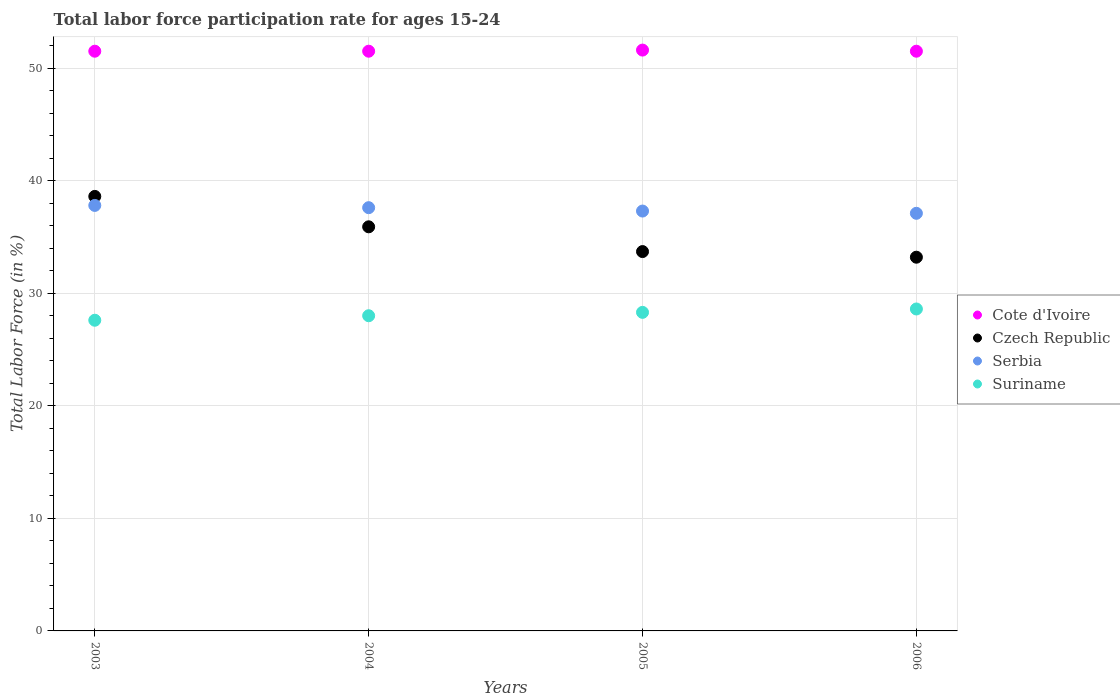How many different coloured dotlines are there?
Offer a terse response. 4. What is the labor force participation rate in Czech Republic in 2003?
Provide a short and direct response. 38.6. Across all years, what is the maximum labor force participation rate in Suriname?
Keep it short and to the point. 28.6. Across all years, what is the minimum labor force participation rate in Cote d'Ivoire?
Your response must be concise. 51.5. In which year was the labor force participation rate in Suriname maximum?
Ensure brevity in your answer.  2006. What is the total labor force participation rate in Czech Republic in the graph?
Provide a short and direct response. 141.4. What is the difference between the labor force participation rate in Cote d'Ivoire in 2004 and that in 2005?
Ensure brevity in your answer.  -0.1. What is the difference between the labor force participation rate in Serbia in 2006 and the labor force participation rate in Cote d'Ivoire in 2005?
Provide a short and direct response. -14.5. What is the average labor force participation rate in Czech Republic per year?
Provide a succinct answer. 35.35. In the year 2003, what is the difference between the labor force participation rate in Serbia and labor force participation rate in Czech Republic?
Provide a short and direct response. -0.8. What is the ratio of the labor force participation rate in Serbia in 2005 to that in 2006?
Your answer should be compact. 1.01. Is the labor force participation rate in Cote d'Ivoire in 2004 less than that in 2006?
Keep it short and to the point. No. Is the difference between the labor force participation rate in Serbia in 2004 and 2005 greater than the difference between the labor force participation rate in Czech Republic in 2004 and 2005?
Keep it short and to the point. No. What is the difference between the highest and the second highest labor force participation rate in Serbia?
Offer a very short reply. 0.2. What is the difference between the highest and the lowest labor force participation rate in Serbia?
Provide a short and direct response. 0.7. Is the sum of the labor force participation rate in Suriname in 2003 and 2004 greater than the maximum labor force participation rate in Serbia across all years?
Give a very brief answer. Yes. Is the labor force participation rate in Czech Republic strictly less than the labor force participation rate in Suriname over the years?
Ensure brevity in your answer.  No. How many dotlines are there?
Offer a terse response. 4. What is the difference between two consecutive major ticks on the Y-axis?
Provide a short and direct response. 10. Does the graph contain any zero values?
Provide a short and direct response. No. What is the title of the graph?
Offer a very short reply. Total labor force participation rate for ages 15-24. What is the label or title of the X-axis?
Keep it short and to the point. Years. What is the label or title of the Y-axis?
Make the answer very short. Total Labor Force (in %). What is the Total Labor Force (in %) in Cote d'Ivoire in 2003?
Your answer should be very brief. 51.5. What is the Total Labor Force (in %) in Czech Republic in 2003?
Your answer should be very brief. 38.6. What is the Total Labor Force (in %) of Serbia in 2003?
Provide a short and direct response. 37.8. What is the Total Labor Force (in %) in Suriname in 2003?
Give a very brief answer. 27.6. What is the Total Labor Force (in %) of Cote d'Ivoire in 2004?
Your answer should be compact. 51.5. What is the Total Labor Force (in %) in Czech Republic in 2004?
Give a very brief answer. 35.9. What is the Total Labor Force (in %) in Serbia in 2004?
Your answer should be compact. 37.6. What is the Total Labor Force (in %) in Suriname in 2004?
Your response must be concise. 28. What is the Total Labor Force (in %) in Cote d'Ivoire in 2005?
Your answer should be compact. 51.6. What is the Total Labor Force (in %) in Czech Republic in 2005?
Provide a succinct answer. 33.7. What is the Total Labor Force (in %) in Serbia in 2005?
Keep it short and to the point. 37.3. What is the Total Labor Force (in %) of Suriname in 2005?
Provide a succinct answer. 28.3. What is the Total Labor Force (in %) in Cote d'Ivoire in 2006?
Ensure brevity in your answer.  51.5. What is the Total Labor Force (in %) of Czech Republic in 2006?
Offer a very short reply. 33.2. What is the Total Labor Force (in %) of Serbia in 2006?
Ensure brevity in your answer.  37.1. What is the Total Labor Force (in %) of Suriname in 2006?
Make the answer very short. 28.6. Across all years, what is the maximum Total Labor Force (in %) in Cote d'Ivoire?
Provide a succinct answer. 51.6. Across all years, what is the maximum Total Labor Force (in %) of Czech Republic?
Your answer should be very brief. 38.6. Across all years, what is the maximum Total Labor Force (in %) of Serbia?
Give a very brief answer. 37.8. Across all years, what is the maximum Total Labor Force (in %) in Suriname?
Your response must be concise. 28.6. Across all years, what is the minimum Total Labor Force (in %) in Cote d'Ivoire?
Make the answer very short. 51.5. Across all years, what is the minimum Total Labor Force (in %) of Czech Republic?
Your answer should be very brief. 33.2. Across all years, what is the minimum Total Labor Force (in %) in Serbia?
Your answer should be very brief. 37.1. Across all years, what is the minimum Total Labor Force (in %) in Suriname?
Offer a terse response. 27.6. What is the total Total Labor Force (in %) of Cote d'Ivoire in the graph?
Make the answer very short. 206.1. What is the total Total Labor Force (in %) in Czech Republic in the graph?
Your answer should be compact. 141.4. What is the total Total Labor Force (in %) in Serbia in the graph?
Offer a very short reply. 149.8. What is the total Total Labor Force (in %) in Suriname in the graph?
Keep it short and to the point. 112.5. What is the difference between the Total Labor Force (in %) in Suriname in 2003 and that in 2004?
Give a very brief answer. -0.4. What is the difference between the Total Labor Force (in %) in Cote d'Ivoire in 2003 and that in 2005?
Your answer should be very brief. -0.1. What is the difference between the Total Labor Force (in %) of Cote d'Ivoire in 2003 and that in 2006?
Make the answer very short. 0. What is the difference between the Total Labor Force (in %) in Serbia in 2003 and that in 2006?
Your answer should be very brief. 0.7. What is the difference between the Total Labor Force (in %) in Suriname in 2003 and that in 2006?
Offer a very short reply. -1. What is the difference between the Total Labor Force (in %) in Czech Republic in 2004 and that in 2005?
Offer a terse response. 2.2. What is the difference between the Total Labor Force (in %) of Serbia in 2004 and that in 2005?
Ensure brevity in your answer.  0.3. What is the difference between the Total Labor Force (in %) of Suriname in 2004 and that in 2005?
Your response must be concise. -0.3. What is the difference between the Total Labor Force (in %) of Cote d'Ivoire in 2004 and that in 2006?
Provide a succinct answer. 0. What is the difference between the Total Labor Force (in %) in Czech Republic in 2004 and that in 2006?
Provide a succinct answer. 2.7. What is the difference between the Total Labor Force (in %) of Serbia in 2004 and that in 2006?
Give a very brief answer. 0.5. What is the difference between the Total Labor Force (in %) of Cote d'Ivoire in 2005 and that in 2006?
Keep it short and to the point. 0.1. What is the difference between the Total Labor Force (in %) of Czech Republic in 2005 and that in 2006?
Keep it short and to the point. 0.5. What is the difference between the Total Labor Force (in %) of Suriname in 2005 and that in 2006?
Ensure brevity in your answer.  -0.3. What is the difference between the Total Labor Force (in %) of Cote d'Ivoire in 2003 and the Total Labor Force (in %) of Czech Republic in 2004?
Provide a succinct answer. 15.6. What is the difference between the Total Labor Force (in %) in Serbia in 2003 and the Total Labor Force (in %) in Suriname in 2004?
Provide a short and direct response. 9.8. What is the difference between the Total Labor Force (in %) in Cote d'Ivoire in 2003 and the Total Labor Force (in %) in Serbia in 2005?
Give a very brief answer. 14.2. What is the difference between the Total Labor Force (in %) of Cote d'Ivoire in 2003 and the Total Labor Force (in %) of Suriname in 2005?
Offer a terse response. 23.2. What is the difference between the Total Labor Force (in %) in Czech Republic in 2003 and the Total Labor Force (in %) in Suriname in 2005?
Ensure brevity in your answer.  10.3. What is the difference between the Total Labor Force (in %) of Cote d'Ivoire in 2003 and the Total Labor Force (in %) of Suriname in 2006?
Your answer should be compact. 22.9. What is the difference between the Total Labor Force (in %) in Serbia in 2003 and the Total Labor Force (in %) in Suriname in 2006?
Your answer should be compact. 9.2. What is the difference between the Total Labor Force (in %) of Cote d'Ivoire in 2004 and the Total Labor Force (in %) of Czech Republic in 2005?
Your response must be concise. 17.8. What is the difference between the Total Labor Force (in %) in Cote d'Ivoire in 2004 and the Total Labor Force (in %) in Suriname in 2005?
Ensure brevity in your answer.  23.2. What is the difference between the Total Labor Force (in %) in Cote d'Ivoire in 2004 and the Total Labor Force (in %) in Czech Republic in 2006?
Provide a succinct answer. 18.3. What is the difference between the Total Labor Force (in %) in Cote d'Ivoire in 2004 and the Total Labor Force (in %) in Suriname in 2006?
Your answer should be compact. 22.9. What is the difference between the Total Labor Force (in %) of Cote d'Ivoire in 2005 and the Total Labor Force (in %) of Serbia in 2006?
Your answer should be very brief. 14.5. What is the difference between the Total Labor Force (in %) of Serbia in 2005 and the Total Labor Force (in %) of Suriname in 2006?
Make the answer very short. 8.7. What is the average Total Labor Force (in %) in Cote d'Ivoire per year?
Your answer should be compact. 51.52. What is the average Total Labor Force (in %) in Czech Republic per year?
Provide a short and direct response. 35.35. What is the average Total Labor Force (in %) in Serbia per year?
Your answer should be very brief. 37.45. What is the average Total Labor Force (in %) of Suriname per year?
Provide a short and direct response. 28.12. In the year 2003, what is the difference between the Total Labor Force (in %) of Cote d'Ivoire and Total Labor Force (in %) of Suriname?
Provide a short and direct response. 23.9. In the year 2003, what is the difference between the Total Labor Force (in %) of Czech Republic and Total Labor Force (in %) of Suriname?
Your answer should be compact. 11. In the year 2004, what is the difference between the Total Labor Force (in %) in Cote d'Ivoire and Total Labor Force (in %) in Suriname?
Offer a very short reply. 23.5. In the year 2004, what is the difference between the Total Labor Force (in %) in Czech Republic and Total Labor Force (in %) in Serbia?
Offer a terse response. -1.7. In the year 2005, what is the difference between the Total Labor Force (in %) of Cote d'Ivoire and Total Labor Force (in %) of Czech Republic?
Your answer should be compact. 17.9. In the year 2005, what is the difference between the Total Labor Force (in %) of Cote d'Ivoire and Total Labor Force (in %) of Serbia?
Your answer should be very brief. 14.3. In the year 2005, what is the difference between the Total Labor Force (in %) in Cote d'Ivoire and Total Labor Force (in %) in Suriname?
Keep it short and to the point. 23.3. In the year 2006, what is the difference between the Total Labor Force (in %) in Cote d'Ivoire and Total Labor Force (in %) in Czech Republic?
Ensure brevity in your answer.  18.3. In the year 2006, what is the difference between the Total Labor Force (in %) of Cote d'Ivoire and Total Labor Force (in %) of Suriname?
Ensure brevity in your answer.  22.9. In the year 2006, what is the difference between the Total Labor Force (in %) in Czech Republic and Total Labor Force (in %) in Suriname?
Your response must be concise. 4.6. In the year 2006, what is the difference between the Total Labor Force (in %) in Serbia and Total Labor Force (in %) in Suriname?
Provide a short and direct response. 8.5. What is the ratio of the Total Labor Force (in %) in Cote d'Ivoire in 2003 to that in 2004?
Offer a terse response. 1. What is the ratio of the Total Labor Force (in %) in Czech Republic in 2003 to that in 2004?
Ensure brevity in your answer.  1.08. What is the ratio of the Total Labor Force (in %) in Suriname in 2003 to that in 2004?
Make the answer very short. 0.99. What is the ratio of the Total Labor Force (in %) in Cote d'Ivoire in 2003 to that in 2005?
Keep it short and to the point. 1. What is the ratio of the Total Labor Force (in %) in Czech Republic in 2003 to that in 2005?
Make the answer very short. 1.15. What is the ratio of the Total Labor Force (in %) of Serbia in 2003 to that in 2005?
Offer a terse response. 1.01. What is the ratio of the Total Labor Force (in %) of Suriname in 2003 to that in 2005?
Your answer should be very brief. 0.98. What is the ratio of the Total Labor Force (in %) of Cote d'Ivoire in 2003 to that in 2006?
Your response must be concise. 1. What is the ratio of the Total Labor Force (in %) in Czech Republic in 2003 to that in 2006?
Ensure brevity in your answer.  1.16. What is the ratio of the Total Labor Force (in %) in Serbia in 2003 to that in 2006?
Your answer should be compact. 1.02. What is the ratio of the Total Labor Force (in %) of Cote d'Ivoire in 2004 to that in 2005?
Your response must be concise. 1. What is the ratio of the Total Labor Force (in %) in Czech Republic in 2004 to that in 2005?
Your response must be concise. 1.07. What is the ratio of the Total Labor Force (in %) in Czech Republic in 2004 to that in 2006?
Provide a succinct answer. 1.08. What is the ratio of the Total Labor Force (in %) of Serbia in 2004 to that in 2006?
Keep it short and to the point. 1.01. What is the ratio of the Total Labor Force (in %) of Suriname in 2004 to that in 2006?
Offer a terse response. 0.98. What is the ratio of the Total Labor Force (in %) of Cote d'Ivoire in 2005 to that in 2006?
Your response must be concise. 1. What is the ratio of the Total Labor Force (in %) of Czech Republic in 2005 to that in 2006?
Provide a succinct answer. 1.02. What is the ratio of the Total Labor Force (in %) of Serbia in 2005 to that in 2006?
Offer a terse response. 1.01. What is the difference between the highest and the second highest Total Labor Force (in %) of Czech Republic?
Ensure brevity in your answer.  2.7. What is the difference between the highest and the lowest Total Labor Force (in %) in Cote d'Ivoire?
Offer a terse response. 0.1. What is the difference between the highest and the lowest Total Labor Force (in %) of Serbia?
Ensure brevity in your answer.  0.7. 